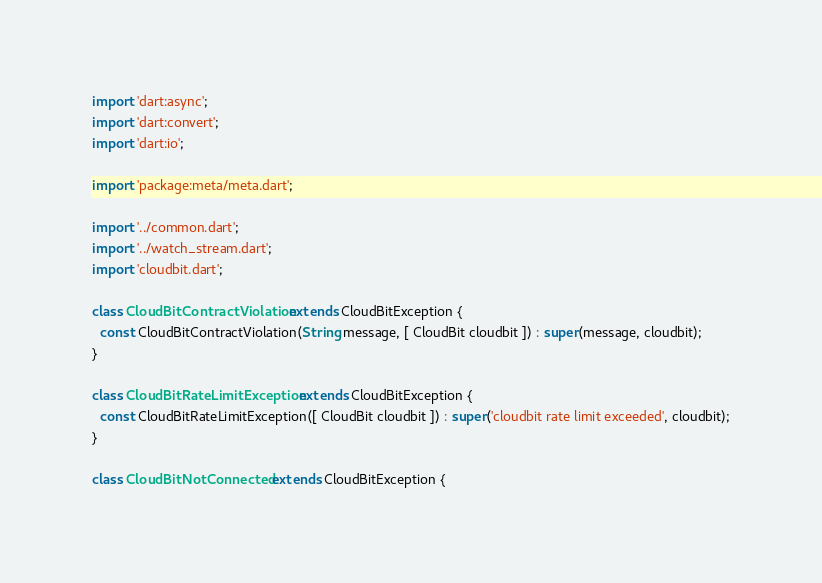Convert code to text. <code><loc_0><loc_0><loc_500><loc_500><_Dart_>import 'dart:async';
import 'dart:convert';
import 'dart:io';

import 'package:meta/meta.dart';

import '../common.dart';
import '../watch_stream.dart';
import 'cloudbit.dart';

class CloudBitContractViolation extends CloudBitException {
  const CloudBitContractViolation(String message, [ CloudBit cloudbit ]) : super(message, cloudbit);
}

class CloudBitRateLimitException extends CloudBitException {
  const CloudBitRateLimitException([ CloudBit cloudbit ]) : super('cloudbit rate limit exceeded', cloudbit);
}

class CloudBitNotConnected extends CloudBitException {</code> 